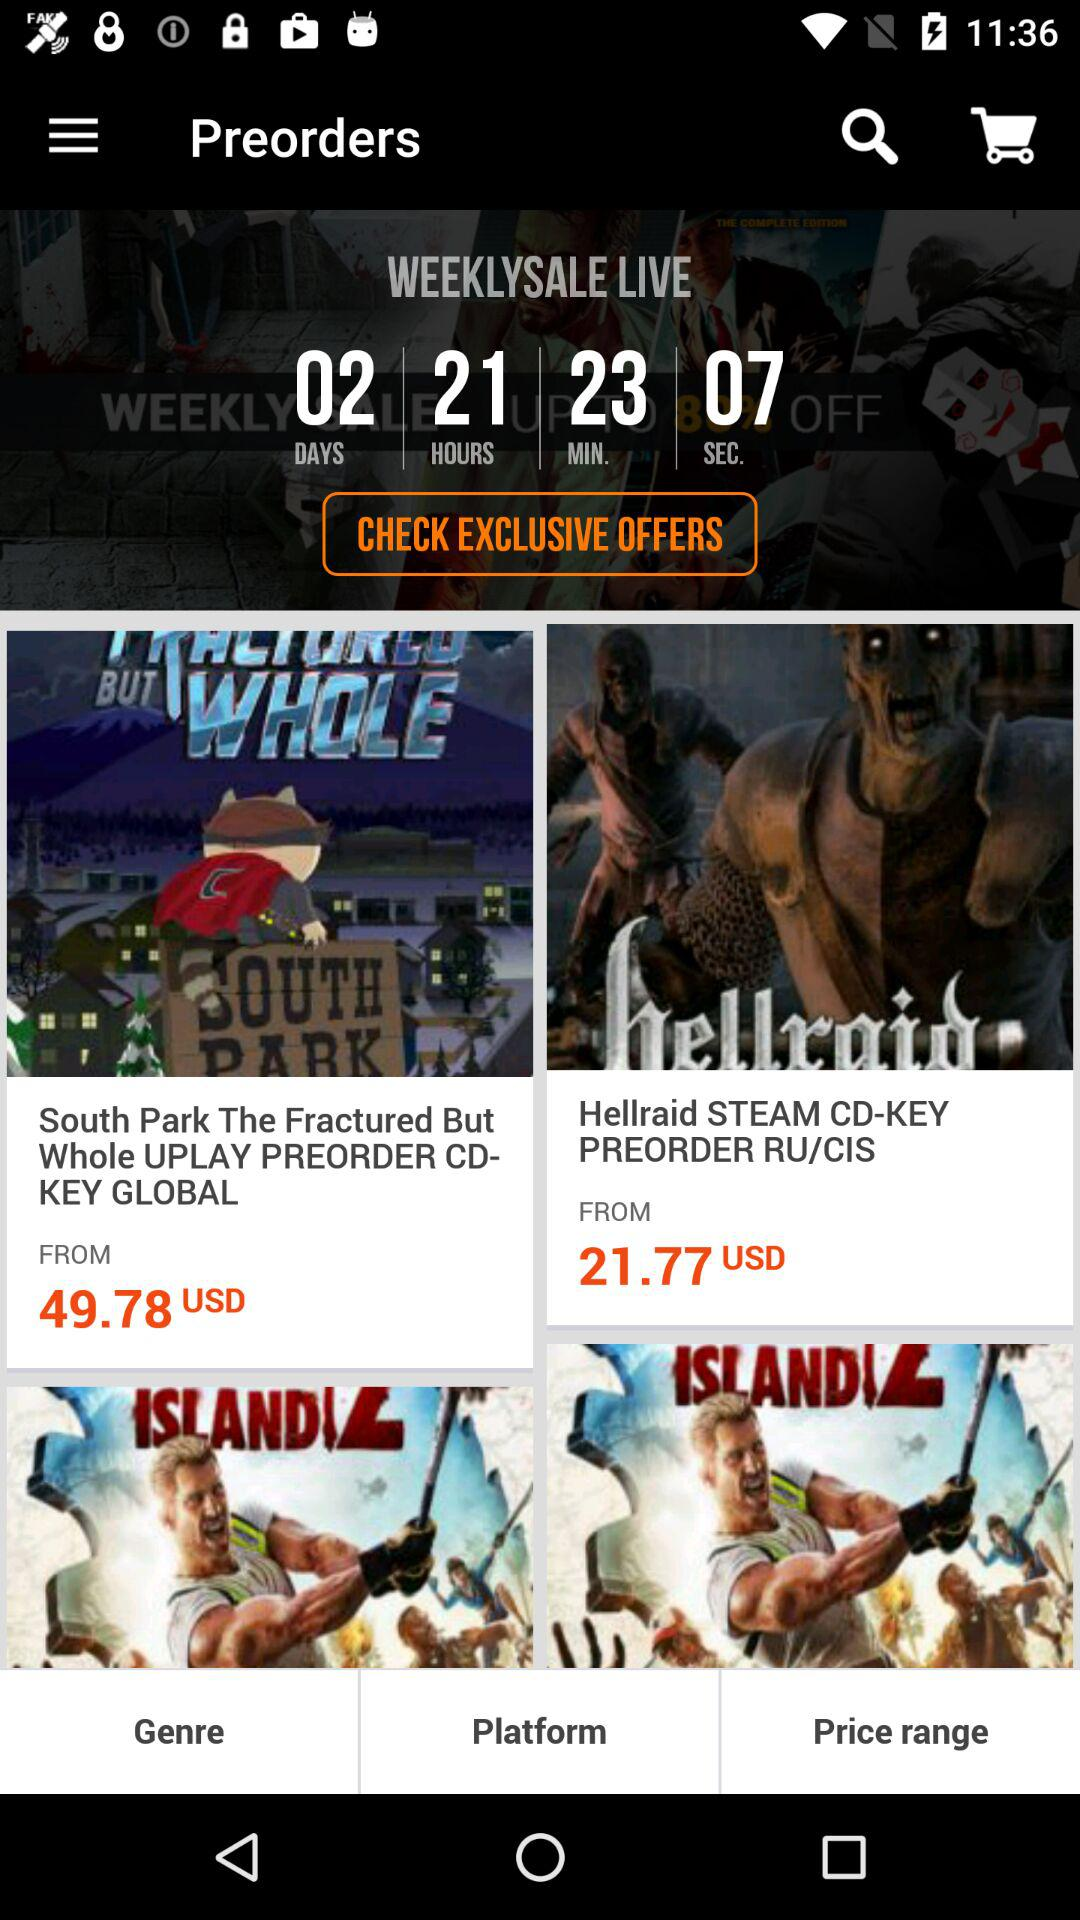In how many days will the weekly sale start? The weekly sale will start in 2 days. 